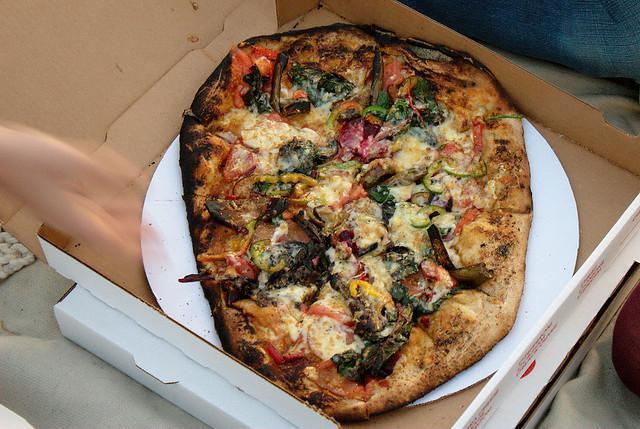How many giraffes are looking at the camera?
Give a very brief answer. 0. 